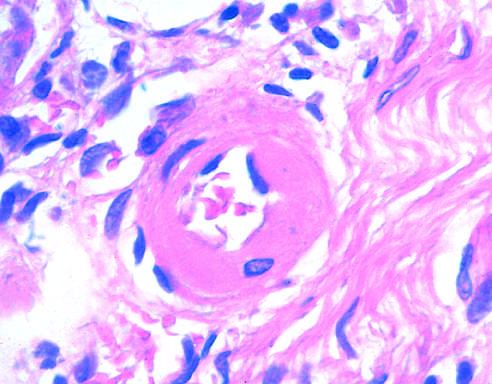what is the arteriolar wall thickened with?
Answer the question using a single word or phrase. The deposition of amorphous proteinaceous material 